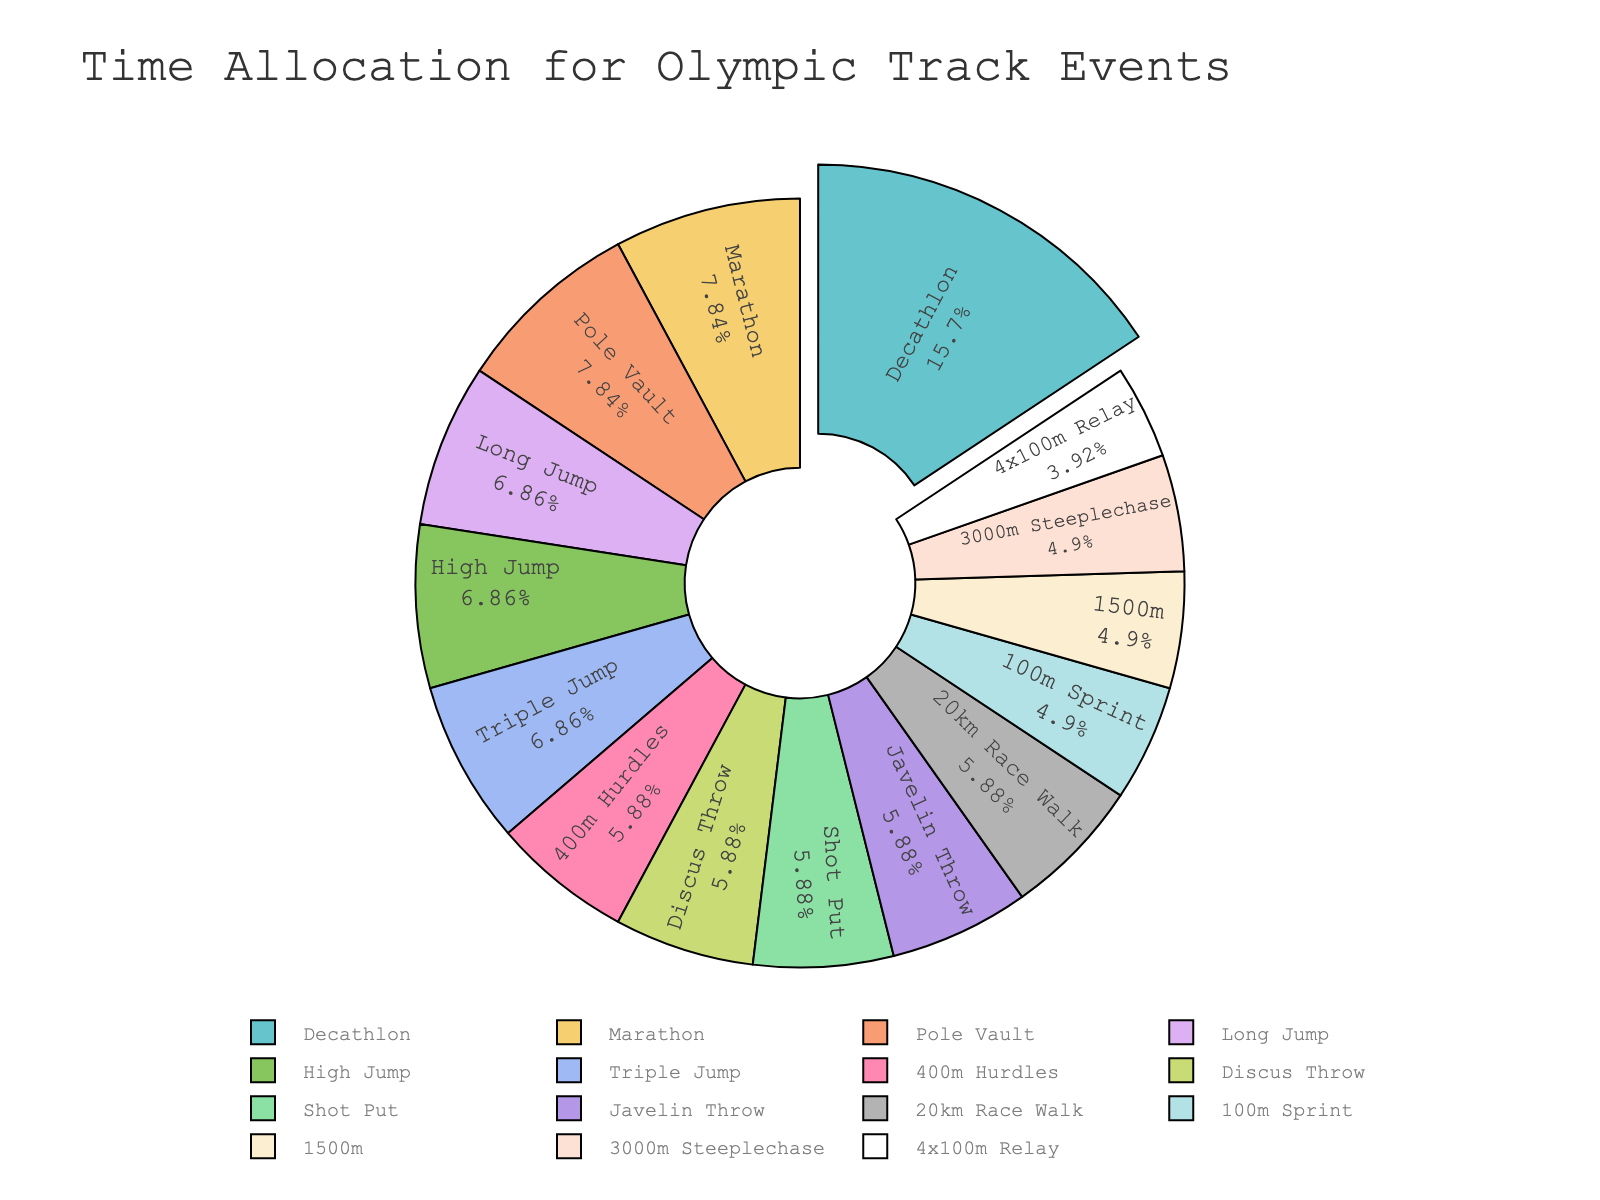Which event takes up the most time in the Olympic track schedule? The event with the largest segment in the pie chart represents the event that takes up the most time. This is the Decathlon.
Answer: Decathlon What is the combined time allocation for the 100m Sprint, 4x100m Relay, and 1500m events? Sum the time allocated for these events: 100m Sprint (2.5 hours) + 4x100m Relay (2 hours) + 1500m (2.5 hours) = 7 hours.
Answer: 7 hours How does the time allocation for the Marathon compare to the Pole Vault? The pie chart shows that both the Marathon and Pole Vault have equal segments, indicating they both take up 4 hours.
Answer: Equal Which event, other than Decathlon, has the highest time allocation? The next largest segment after Decathlon can be identified. This is split among the Marathon and Pole Vault.
Answer: Marathon or Pole Vault What proportion of the total time is allocated to the High Jump? Find the segment labeled High Jump and look at its proportion. The High Jump takes up 3.5 hours.
Answer: 3.5 hours What is the difference in time allocation between the 3000m Steeplechase and the 20km Race Walk? Subtract the time of the 3000m Steeplechase (2.5 hours) from the 20km Race Walk (3 hours). 3 - 2.5 = 0.5 hours.
Answer: 0.5 hours Which events have the same time allocation as the Shot Put? The Shot Put segment can be compared with others to find matching allocations: Long Jump, 400m Hurdles, Javelin Throw, 20km Race Walk, and Discus Throw all have 3 hours each.
Answer: Long Jump, 400m Hurdles, Javelin Throw, 20km Race Walk, Discus Throw What is the average time allocation for the High Jump, Triple Jump, and Long Jump events? Sum the times and divide by the number of events: (3.5 + 3.5 + 3.5) / 3 = 3.5 hours.
Answer: 3.5 hours 